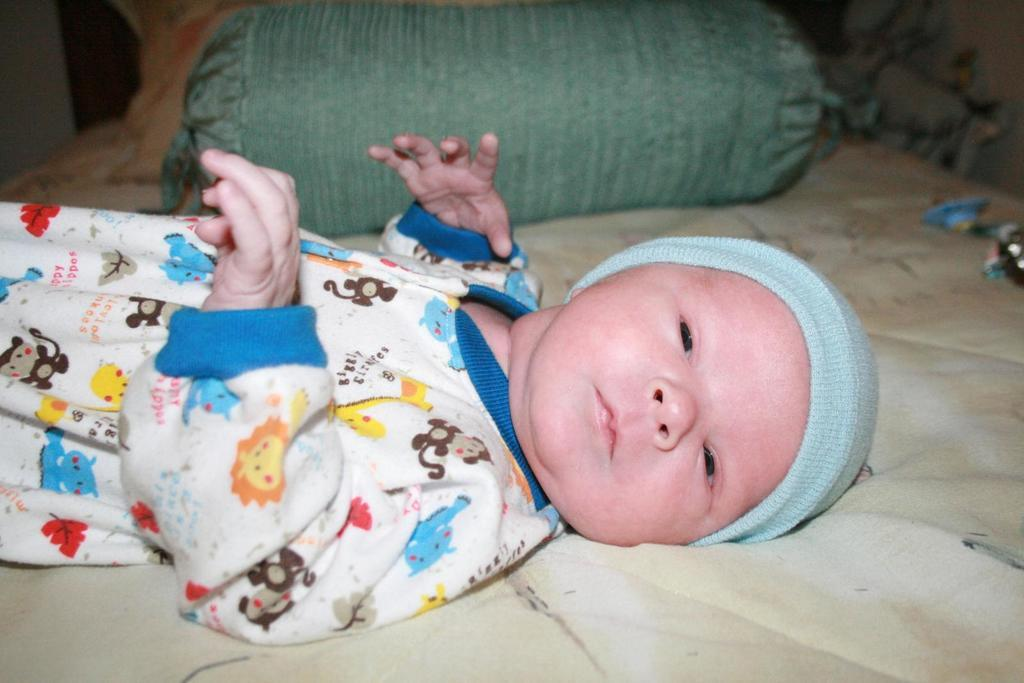What is the main subject of the picture? The main subject of the picture is a baby. Where is the baby located in the image? The baby is laying on a bed. What type of cushion is on the bed? There is a roll cushion on the bed. Are there any other items on the bed besides the baby and the roll cushion? Yes, there are other unspecified things on the bed. Can you see any bees buzzing around the baby in the image? No, there are no bees present in the image. Is there a garden visible in the background of the image? No, there is no garden visible in the image; it only shows the baby on a bed with a roll cushion and other unspecified items. 